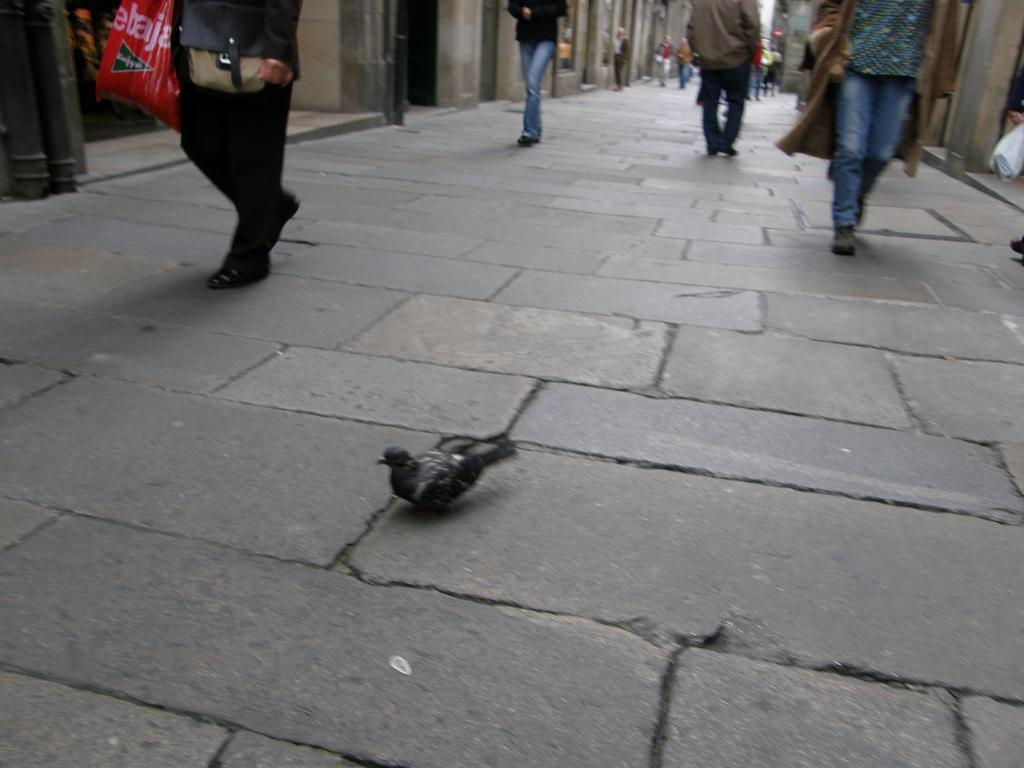How would you summarize this image in a sentence or two? In this image there are few people walking on the road and there is a bird. On the left and right side of the image there are buildings. 